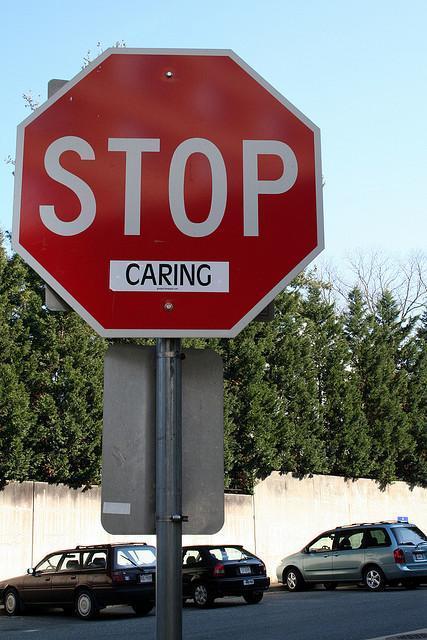How many cars in this scene?
Give a very brief answer. 3. How many cars are in the picture?
Give a very brief answer. 3. How many cars are there?
Give a very brief answer. 3. How many people are wearing pink?
Give a very brief answer. 0. 